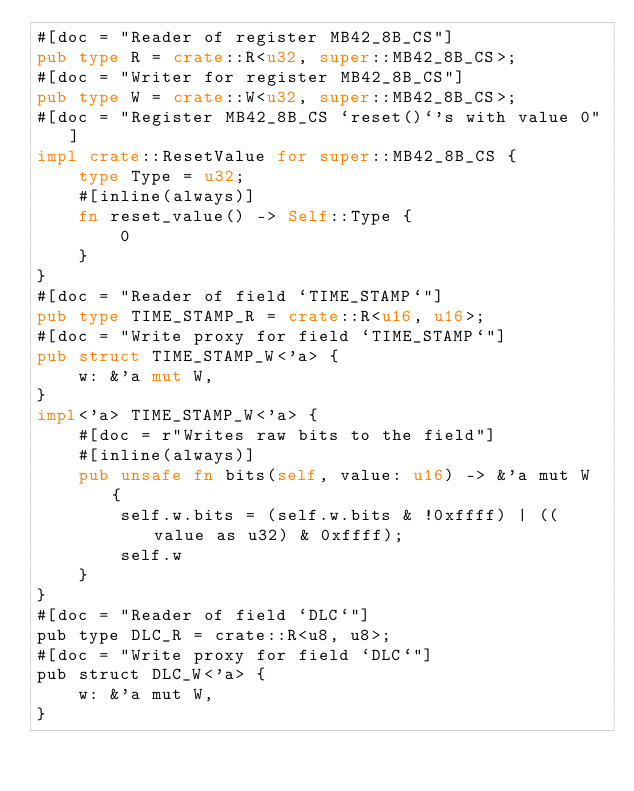Convert code to text. <code><loc_0><loc_0><loc_500><loc_500><_Rust_>#[doc = "Reader of register MB42_8B_CS"]
pub type R = crate::R<u32, super::MB42_8B_CS>;
#[doc = "Writer for register MB42_8B_CS"]
pub type W = crate::W<u32, super::MB42_8B_CS>;
#[doc = "Register MB42_8B_CS `reset()`'s with value 0"]
impl crate::ResetValue for super::MB42_8B_CS {
    type Type = u32;
    #[inline(always)]
    fn reset_value() -> Self::Type {
        0
    }
}
#[doc = "Reader of field `TIME_STAMP`"]
pub type TIME_STAMP_R = crate::R<u16, u16>;
#[doc = "Write proxy for field `TIME_STAMP`"]
pub struct TIME_STAMP_W<'a> {
    w: &'a mut W,
}
impl<'a> TIME_STAMP_W<'a> {
    #[doc = r"Writes raw bits to the field"]
    #[inline(always)]
    pub unsafe fn bits(self, value: u16) -> &'a mut W {
        self.w.bits = (self.w.bits & !0xffff) | ((value as u32) & 0xffff);
        self.w
    }
}
#[doc = "Reader of field `DLC`"]
pub type DLC_R = crate::R<u8, u8>;
#[doc = "Write proxy for field `DLC`"]
pub struct DLC_W<'a> {
    w: &'a mut W,
}</code> 